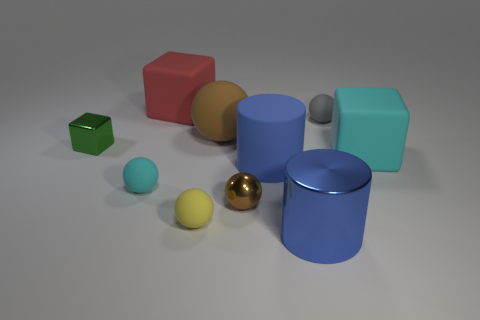There is another sphere that is the same color as the big sphere; what is its size?
Make the answer very short. Small. Is the color of the matte object that is to the right of the gray thing the same as the rubber sphere left of the large red matte cube?
Offer a terse response. Yes. Is the number of large rubber blocks on the left side of the brown metal thing the same as the number of tiny matte spheres to the right of the big blue rubber cylinder?
Your response must be concise. Yes. What is the tiny gray ball made of?
Offer a very short reply. Rubber. What is the material of the tiny ball that is behind the green metallic object?
Ensure brevity in your answer.  Rubber. Are there more large cubes that are on the right side of the tiny gray sphere than tiny gray matte blocks?
Your answer should be very brief. Yes. Is there a large brown object that is to the left of the shiny cylinder that is in front of the blue cylinder that is behind the big shiny thing?
Your answer should be very brief. Yes. Are there any big metallic cylinders left of the small yellow sphere?
Make the answer very short. No. What number of things are the same color as the matte cylinder?
Make the answer very short. 1. The gray thing that is made of the same material as the red object is what size?
Keep it short and to the point. Small. 